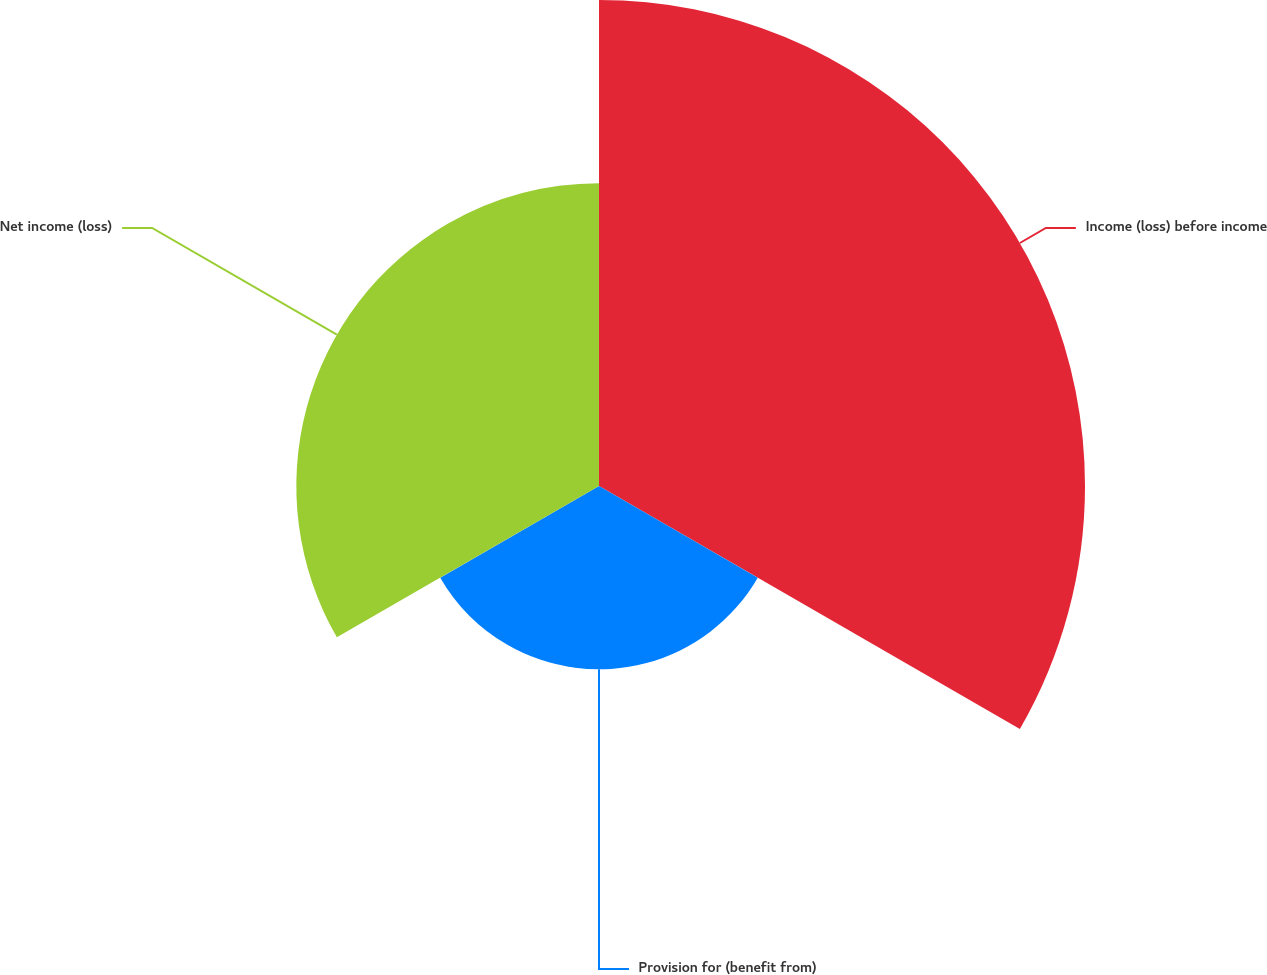Convert chart. <chart><loc_0><loc_0><loc_500><loc_500><pie_chart><fcel>Income (loss) before income<fcel>Provision for (benefit from)<fcel>Net income (loss)<nl><fcel>50.0%<fcel>18.86%<fcel>31.14%<nl></chart> 